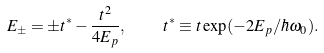Convert formula to latex. <formula><loc_0><loc_0><loc_500><loc_500>E _ { \pm } = \pm t ^ { * } - \frac { t ^ { 2 } } { 4 E _ { p } } , \quad t ^ { * } \equiv t \exp ( - 2 E _ { p } / \hbar { \omega } _ { 0 } ) .</formula> 